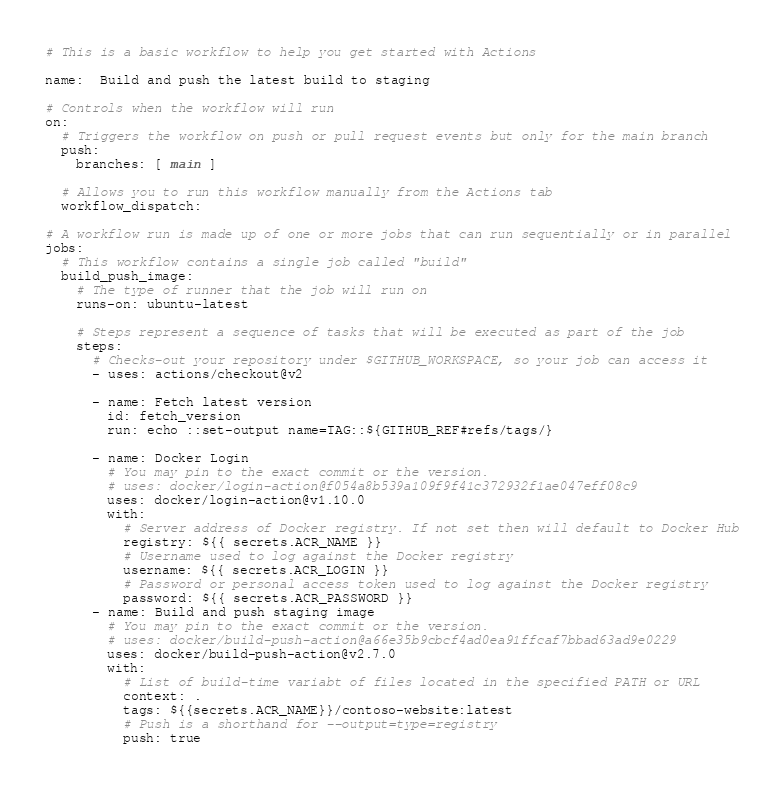Convert code to text. <code><loc_0><loc_0><loc_500><loc_500><_YAML_># This is a basic workflow to help you get started with Actions

name:  Build and push the latest build to staging

# Controls when the workflow will run
on:
  # Triggers the workflow on push or pull request events but only for the main branch
  push:
    branches: [ main ]

  # Allows you to run this workflow manually from the Actions tab
  workflow_dispatch:

# A workflow run is made up of one or more jobs that can run sequentially or in parallel
jobs:
  # This workflow contains a single job called "build"
  build_push_image:
    # The type of runner that the job will run on
    runs-on: ubuntu-latest

    # Steps represent a sequence of tasks that will be executed as part of the job
    steps:
      # Checks-out your repository under $GITHUB_WORKSPACE, so your job can access it
      - uses: actions/checkout@v2
      
      - name: Fetch latest version
        id: fetch_version
        run: echo ::set-output name=TAG::${GITHUB_REF#refs/tags/}
              
      - name: Docker Login
        # You may pin to the exact commit or the version.
        # uses: docker/login-action@f054a8b539a109f9f41c372932f1ae047eff08c9
        uses: docker/login-action@v1.10.0
        with:
          # Server address of Docker registry. If not set then will default to Docker Hub
          registry: ${{ secrets.ACR_NAME }}
          # Username used to log against the Docker registry
          username: ${{ secrets.ACR_LOGIN }}
          # Password or personal access token used to log against the Docker registry
          password: ${{ secrets.ACR_PASSWORD }}
      - name: Build and push staging image
        # You may pin to the exact commit or the version.
        # uses: docker/build-push-action@a66e35b9cbcf4ad0ea91ffcaf7bbad63ad9e0229
        uses: docker/build-push-action@v2.7.0
        with:
          # List of build-time variabt of files located in the specified PATH or URL
          context: .
          tags: ${{secrets.ACR_NAME}}/contoso-website:latest
          # Push is a shorthand for --output=type=registry
          push: true
 
</code> 